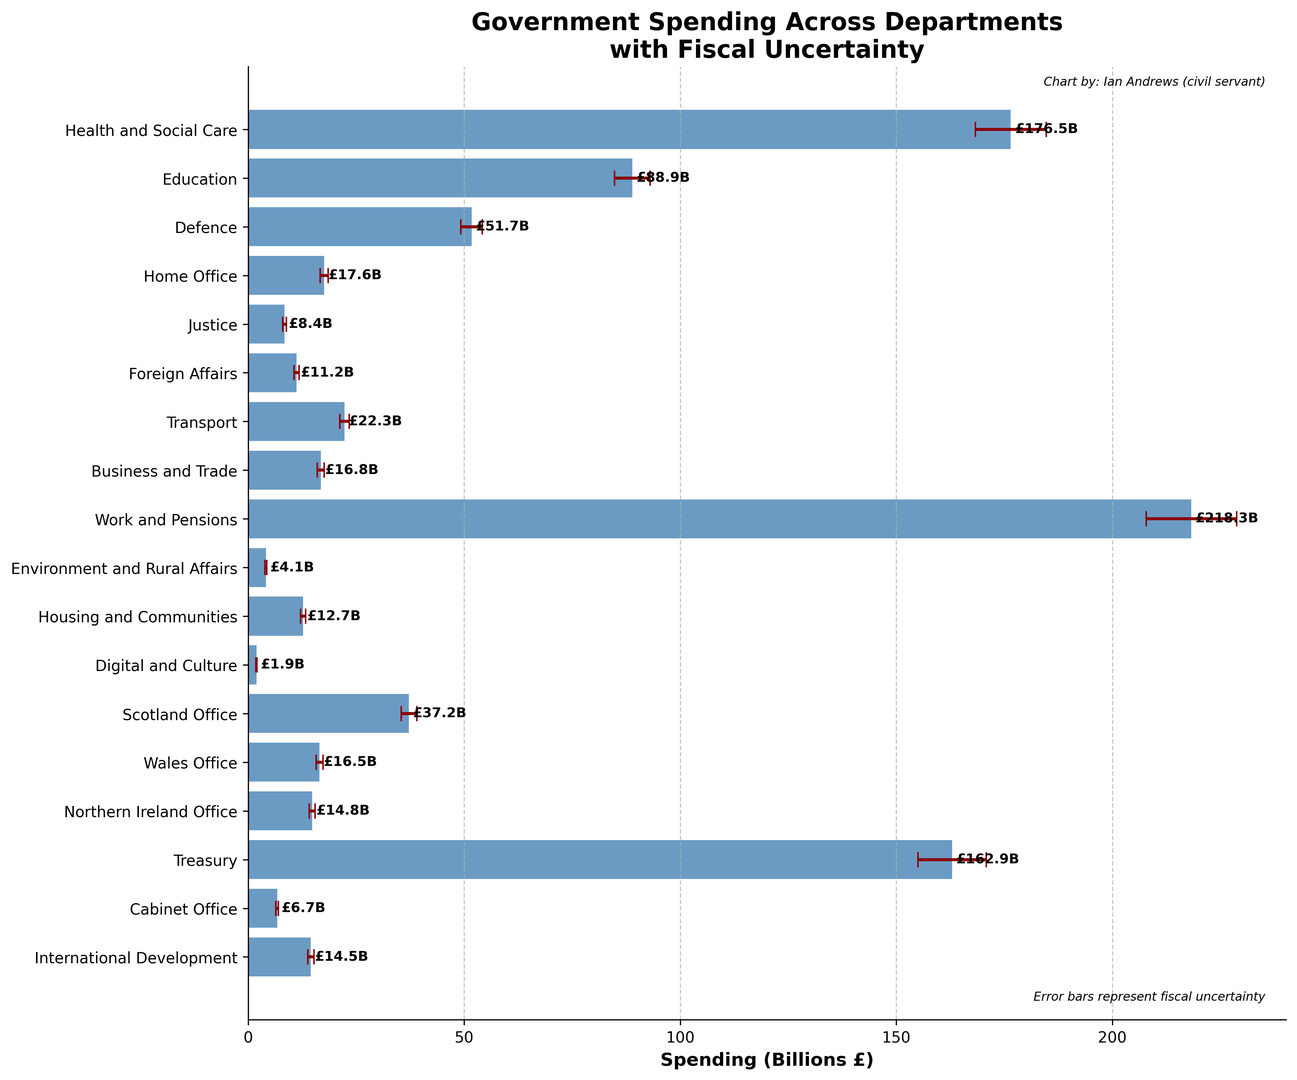What are the top three departments in terms of government spending? By looking at the horizontal bar lengths, we can see that the top three departments with the highest spending are "Work and Pensions", "Health and Social Care", and "Treasury".
Answer: Work and Pensions, Health and Social Care, Treasury Which department has the smallest error margin? By observing the size of the error bars, "Digital and Culture" has the smallest error margin at 0.1 billions.
Answer: Digital and Culture What is the difference in spending between the highest and lowest spending departments? The highest spending is "Work and Pensions" at 218.3 billions and the lowest is "Digital and Culture" at 1.9 billions. The difference is 218.3 - 1.9.
Answer: 216.4 billions Compare the spending on Health and Social Care to that of Defence. Which one is greater and by how much? Health and Social Care has a spending of 176.5 billions while Defence has 51.7 billions. The difference is 176.5 - 51.7.
Answer: Health and Social Care is greater by 124.8 billions What is the combined spending of the Home Office, Justice, and Foreign Affairs? The spending for Home Office, Justice, and Foreign Affairs are 17.6, 8.4, and 11.2 billions respectively. Their combined spending is 17.6 + 8.4 + 11.2.
Answer: 37.2 billions How does the error margin for Work and Pensions compare to the error margin for Health and Social Care? The error margin for Work and Pensions is 10.5 billions, while for Health and Social Care it is 8.2 billions. Thus, Work and Pensions has a higher error margin by 2.3 billions.
Answer: Work and Pensions has a higher error margin by 2.3 billions What is the average spending across all departments? Summing up the spending for all departments and dividing by the number of departments (19). The total spending is 877.9 billions, so the average is 877.9 / 19.
Answer: 46.2 billions Is the spending on Education greater than the combined spending of the Home Office and Defence? Education spending is 88.9 billions. The combined spending of the Home Office and Defence is 17.6 + 51.7 = 69.3 billions, which is less than 88.9 billions.
Answer: Yes Which department has the largest error margin relative to its spending? To find this, divide the error margin by the spending for each department and find the largest ratio. Work and Pensions: 10.5 / 218.3 = ~0.048, Health and Social Care: 8.2 / 176.5 = ~0.046, Treasury: 7.9 / 162.9 = ~0.048 etc. "Work and Pensions" and "Treasury" have the largest relative error margin at approximately 0.048.
Answer: Work and Pensions and Treasury 